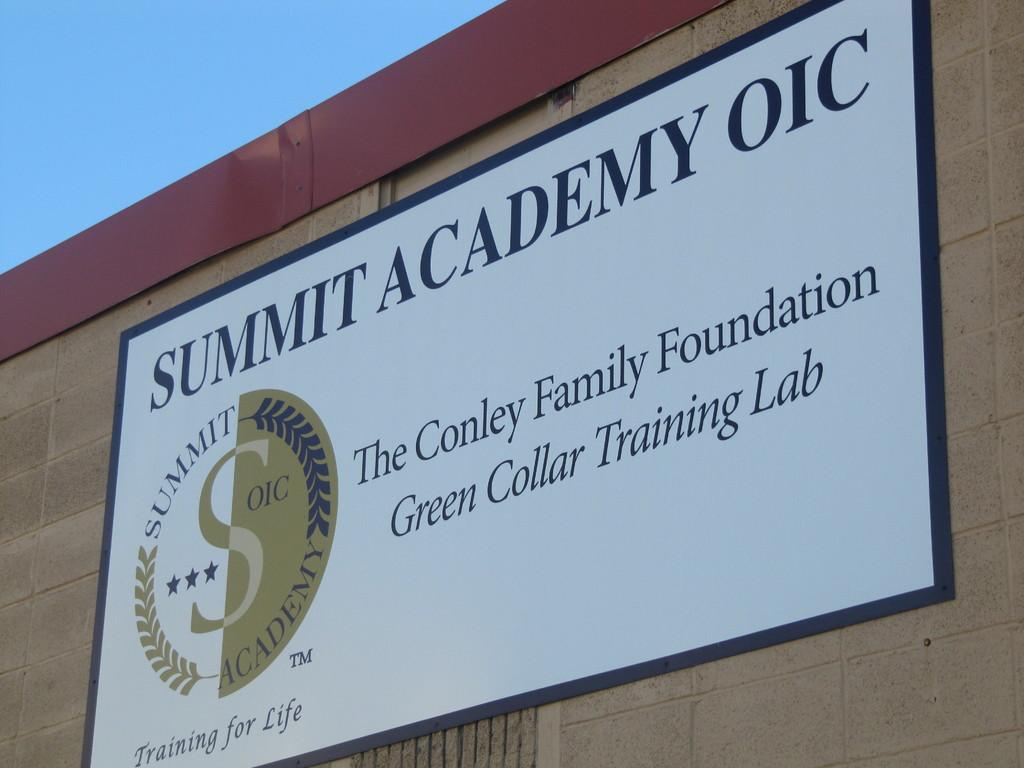<image>
Write a terse but informative summary of the picture. A sign for Summit Academy hangs on the side of a building. 